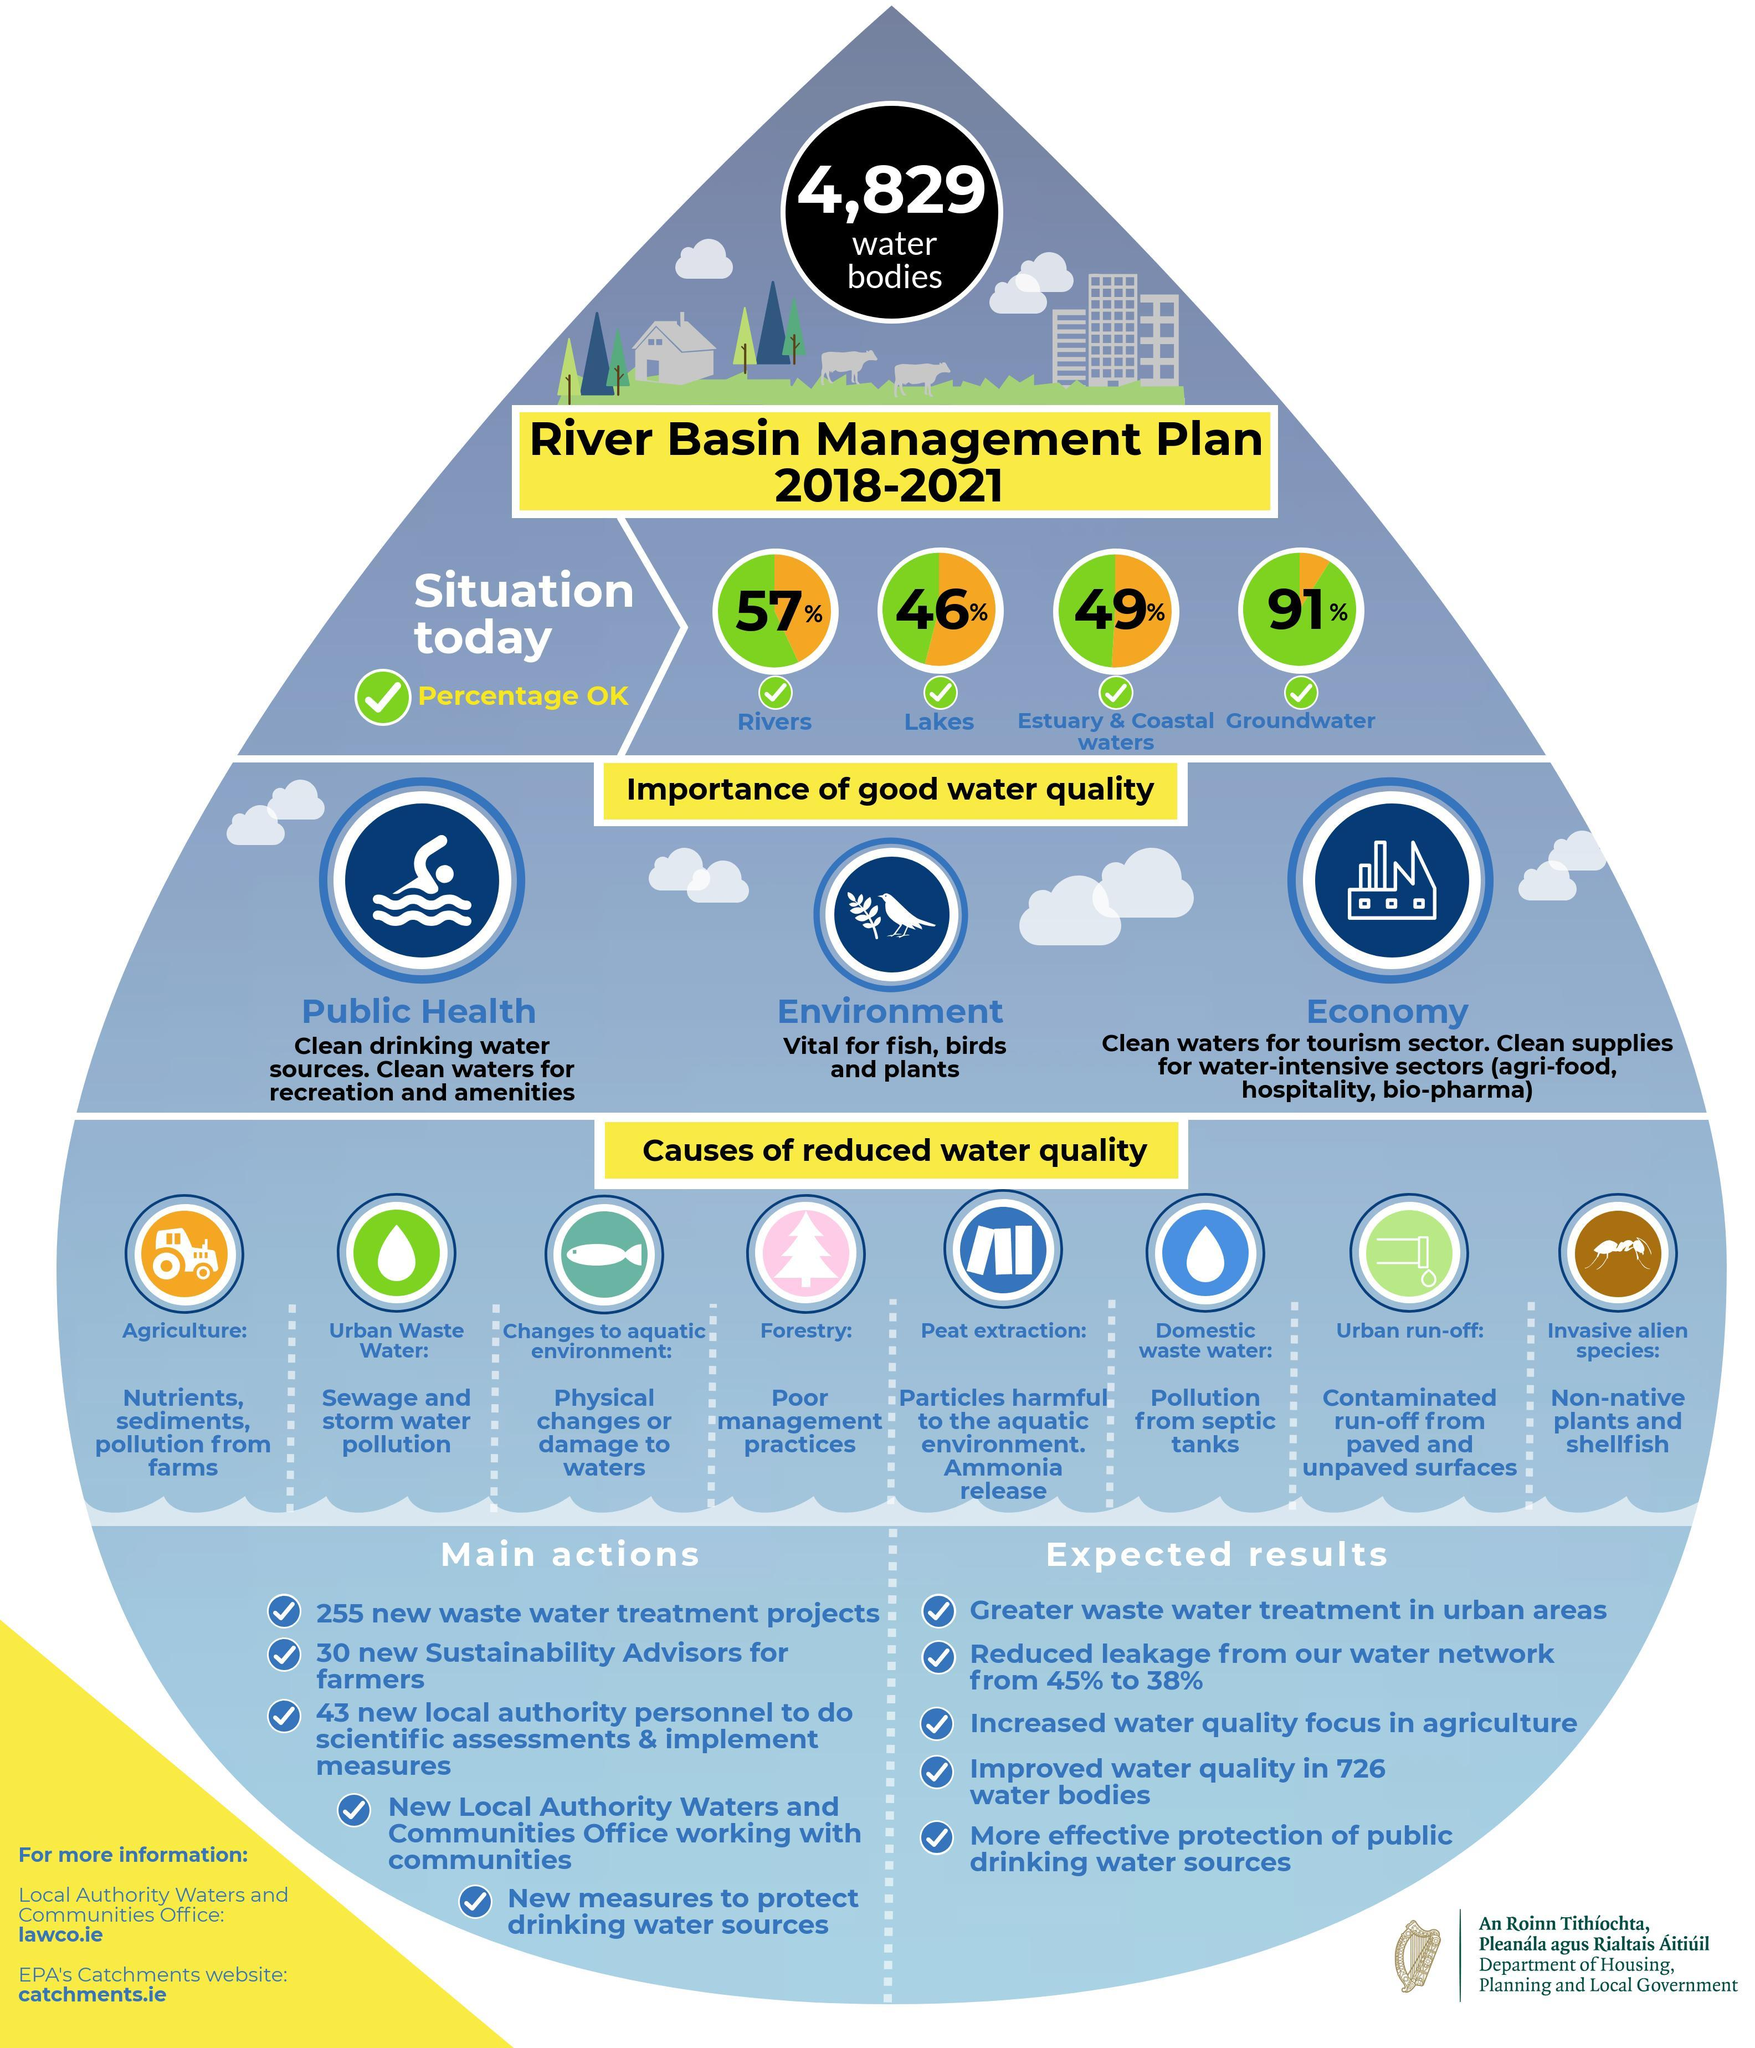What percent of water in rivers is not OK?
Answer the question with a short phrase. 43% 